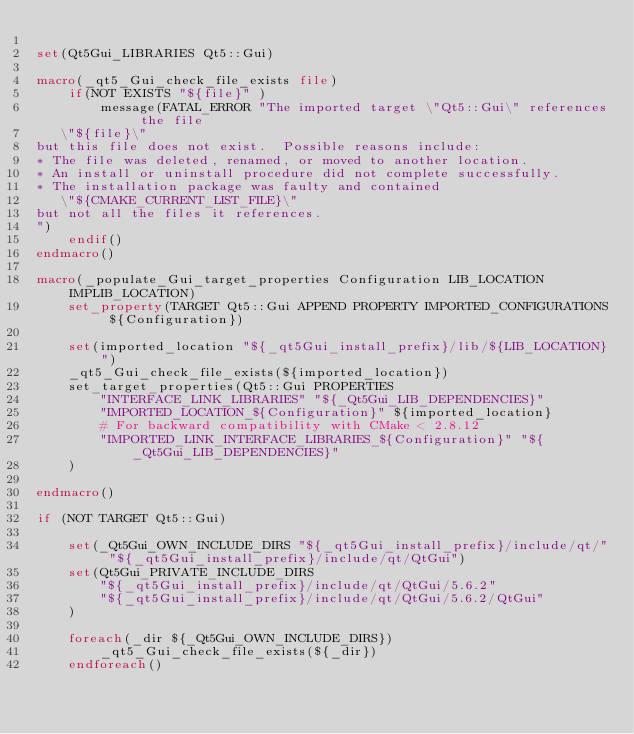<code> <loc_0><loc_0><loc_500><loc_500><_CMake_>
set(Qt5Gui_LIBRARIES Qt5::Gui)

macro(_qt5_Gui_check_file_exists file)
    if(NOT EXISTS "${file}" )
        message(FATAL_ERROR "The imported target \"Qt5::Gui\" references the file
   \"${file}\"
but this file does not exist.  Possible reasons include:
* The file was deleted, renamed, or moved to another location.
* An install or uninstall procedure did not complete successfully.
* The installation package was faulty and contained
   \"${CMAKE_CURRENT_LIST_FILE}\"
but not all the files it references.
")
    endif()
endmacro()

macro(_populate_Gui_target_properties Configuration LIB_LOCATION IMPLIB_LOCATION)
    set_property(TARGET Qt5::Gui APPEND PROPERTY IMPORTED_CONFIGURATIONS ${Configuration})

    set(imported_location "${_qt5Gui_install_prefix}/lib/${LIB_LOCATION}")
    _qt5_Gui_check_file_exists(${imported_location})
    set_target_properties(Qt5::Gui PROPERTIES
        "INTERFACE_LINK_LIBRARIES" "${_Qt5Gui_LIB_DEPENDENCIES}"
        "IMPORTED_LOCATION_${Configuration}" ${imported_location}
        # For backward compatibility with CMake < 2.8.12
        "IMPORTED_LINK_INTERFACE_LIBRARIES_${Configuration}" "${_Qt5Gui_LIB_DEPENDENCIES}"
    )

endmacro()

if (NOT TARGET Qt5::Gui)

    set(_Qt5Gui_OWN_INCLUDE_DIRS "${_qt5Gui_install_prefix}/include/qt/" "${_qt5Gui_install_prefix}/include/qt/QtGui")
    set(Qt5Gui_PRIVATE_INCLUDE_DIRS
        "${_qt5Gui_install_prefix}/include/qt/QtGui/5.6.2"
        "${_qt5Gui_install_prefix}/include/qt/QtGui/5.6.2/QtGui"
    )

    foreach(_dir ${_Qt5Gui_OWN_INCLUDE_DIRS})
        _qt5_Gui_check_file_exists(${_dir})
    endforeach()
</code> 